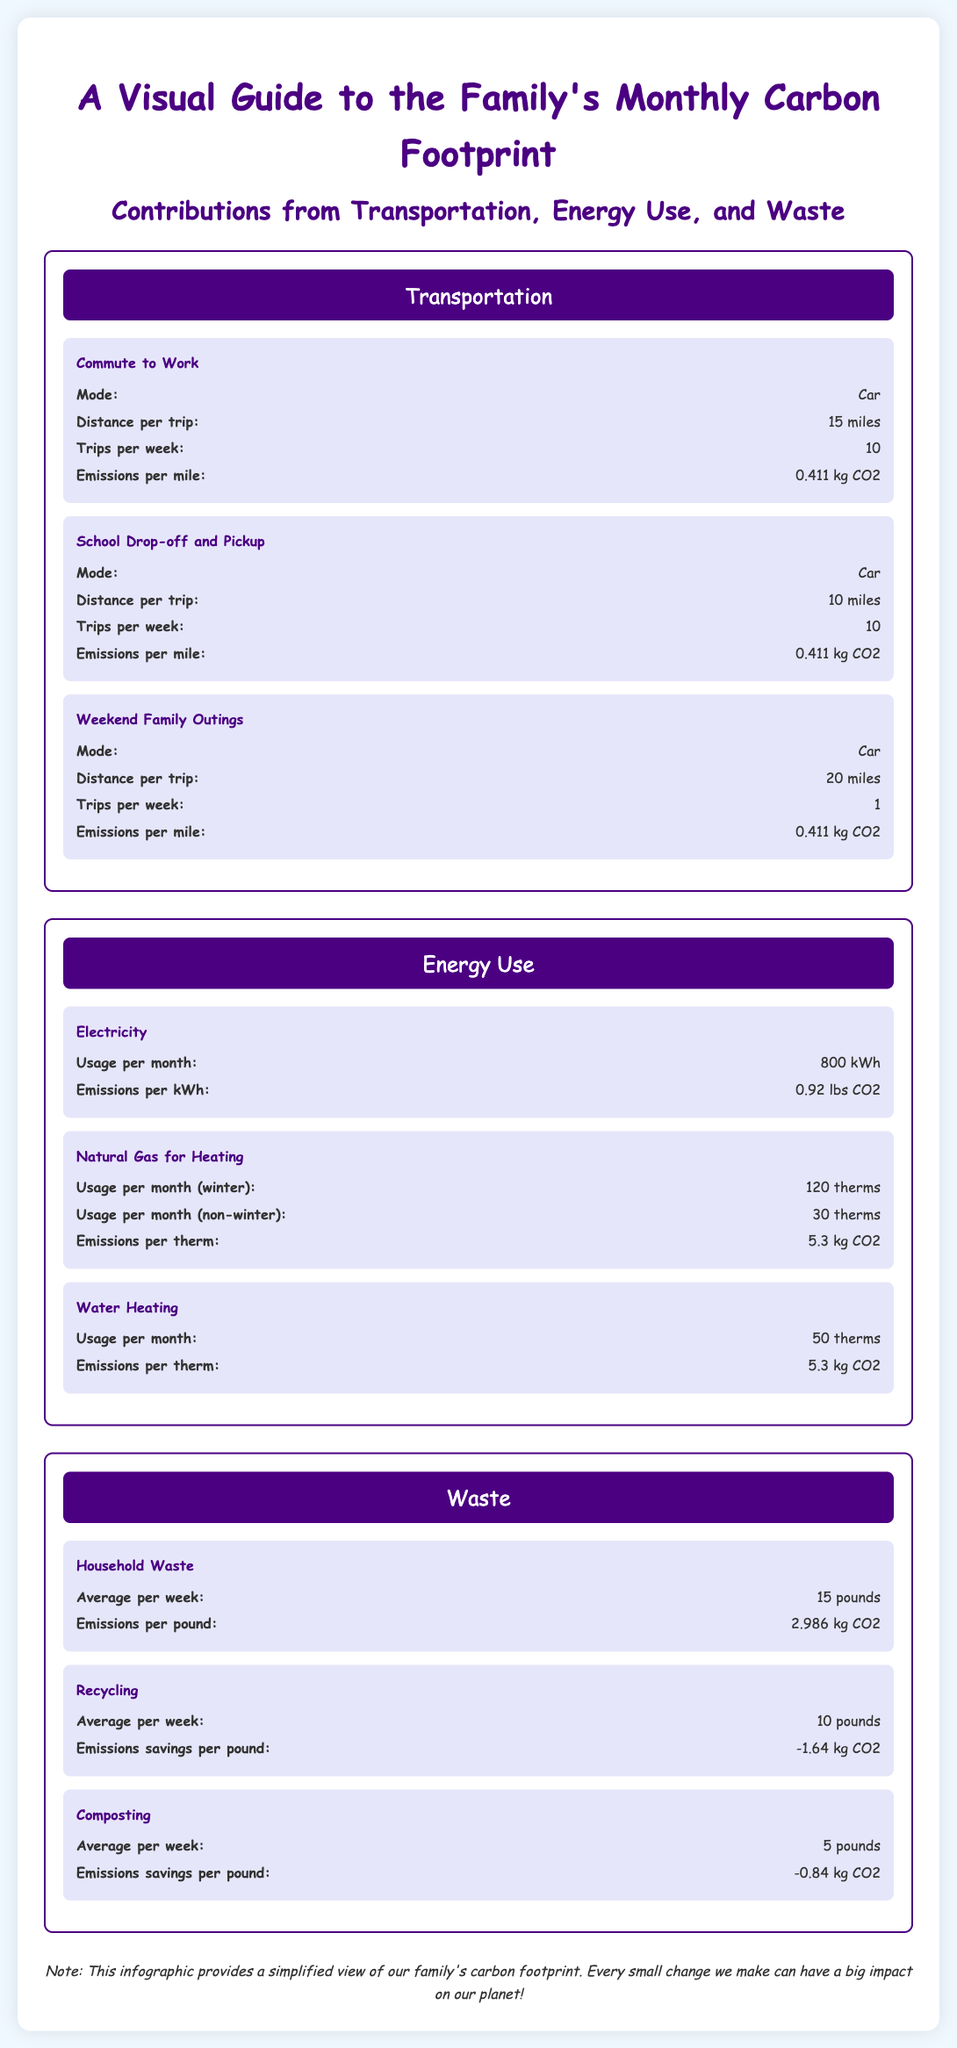What is the distance per trip for commuting to work? The document states that the distance per trip for commuting to work is 15 miles.
Answer: 15 miles How many trips do they take for school drop-off and pickup per week? The document indicates that there are 10 trips per week for school drop-off and pickup.
Answer: 10 What is the emissions per kWh of electricity usage? The emissions per kWh of electricity usage, as mentioned in the document, is 0.92 pounds CO2.
Answer: 0.92 lbs CO2 How much average household waste is produced per week? The document shows an average household waste production of 15 pounds per week.
Answer: 15 pounds What is the emissions savings per pound from recycling? The document states that the emissions savings per pound from recycling is -1.64 kg CO2.
Answer: -1.64 kg CO2 What mode of transportation is used for weekend family outings? The document specifies that the mode of transportation used for weekend family outings is a car.
Answer: Car How much natural gas is used for heating during winter? According to the document, the usage per month for natural gas heating in winter is 120 therms.
Answer: 120 therms What are the emissions per pound for composting? The emissions savings per pound for composting, as stated in the document, is -0.84 kg CO2.
Answer: -0.84 kg CO2 What section does the infographic break down waste into? The infographic breaks down waste into three subsections: Household Waste, Recycling, and Composting.
Answer: Household Waste, Recycling, Composting 